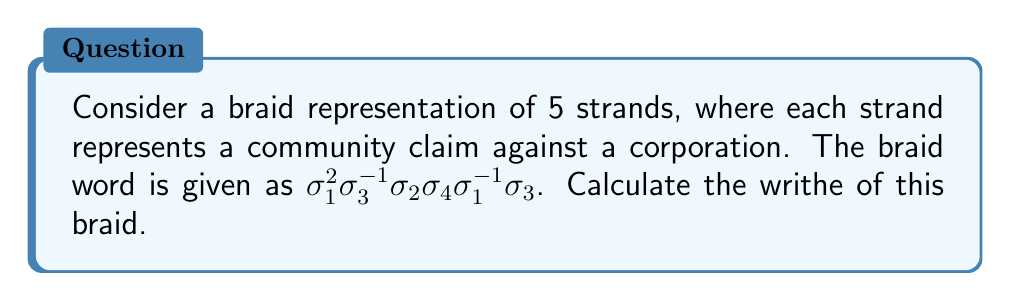Give your solution to this math problem. To calculate the writhe of the braid, we need to follow these steps:

1) Recall that the writhe is the sum of the signs of all crossings in the braid diagram.

2) In braid notation:
   - $\sigma_i$ represents a positive crossing (contributing +1 to the writhe)
   - $\sigma_i^{-1}$ represents a negative crossing (contributing -1 to the writhe)

3) Let's count the crossings in our braid word:

   $\sigma_1^2$: Two positive crossings (+2)
   $\sigma_3^{-1}$: One negative crossing (-1)
   $\sigma_2$: One positive crossing (+1)
   $\sigma_4$: One positive crossing (+1)
   $\sigma_1^{-1}$: One negative crossing (-1)
   $\sigma_3$: One positive crossing (+1)

4) Sum up all the contributions:

   Writhe = 2 + (-1) + 1 + 1 + (-1) + 1 = 3

Therefore, the writhe of this braid is 3.
Answer: 3 